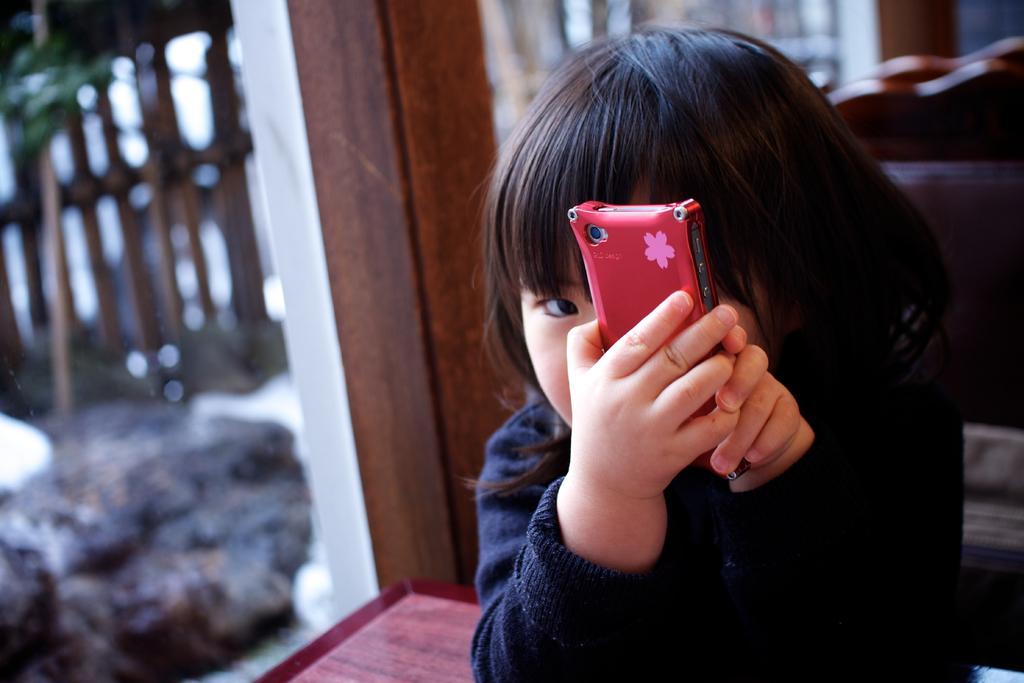In one or two sentences, can you explain what this image depicts? In the image there is a girl holding a mobile. In background we can see pillars and table. 